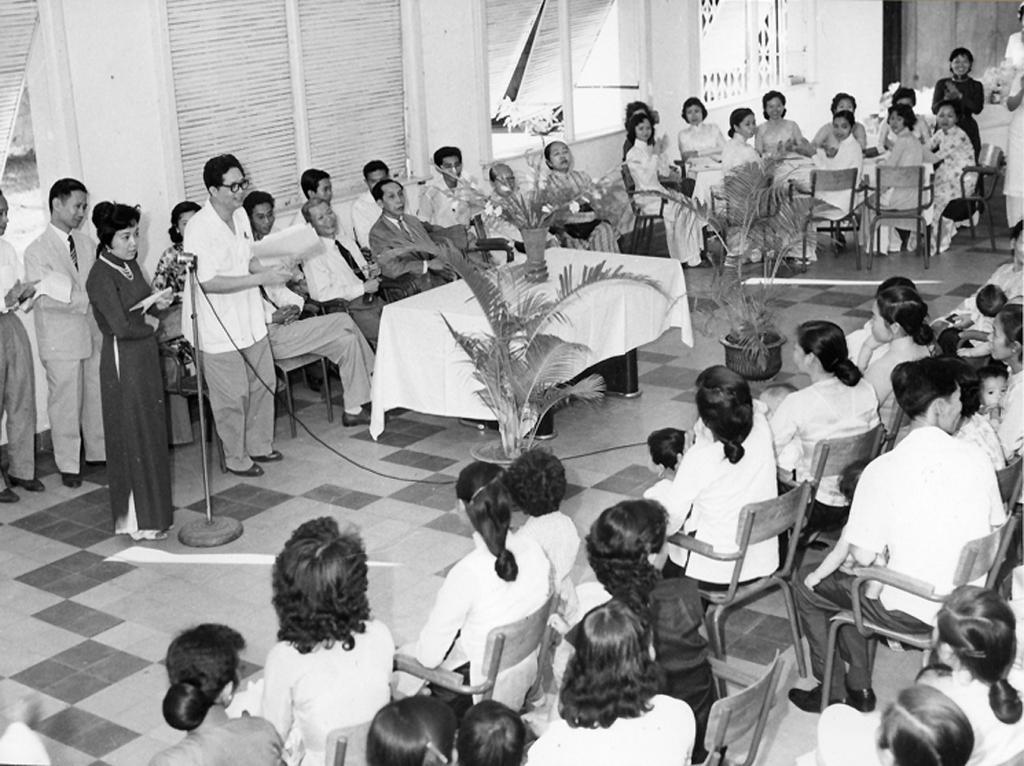Please provide a concise description of this image. This is a black and white image. In this image we can see persons sitting on the chairs and some are standing on the floor. In addition to this there are house plants, flower vase on a table, blinds to the windows, stationary, mic attached to the mic stand and cables. 